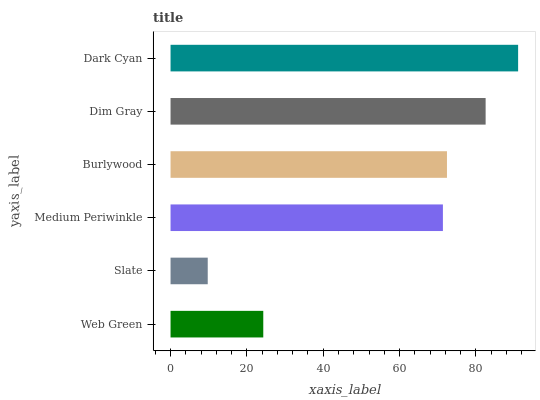Is Slate the minimum?
Answer yes or no. Yes. Is Dark Cyan the maximum?
Answer yes or no. Yes. Is Medium Periwinkle the minimum?
Answer yes or no. No. Is Medium Periwinkle the maximum?
Answer yes or no. No. Is Medium Periwinkle greater than Slate?
Answer yes or no. Yes. Is Slate less than Medium Periwinkle?
Answer yes or no. Yes. Is Slate greater than Medium Periwinkle?
Answer yes or no. No. Is Medium Periwinkle less than Slate?
Answer yes or no. No. Is Burlywood the high median?
Answer yes or no. Yes. Is Medium Periwinkle the low median?
Answer yes or no. Yes. Is Dim Gray the high median?
Answer yes or no. No. Is Burlywood the low median?
Answer yes or no. No. 